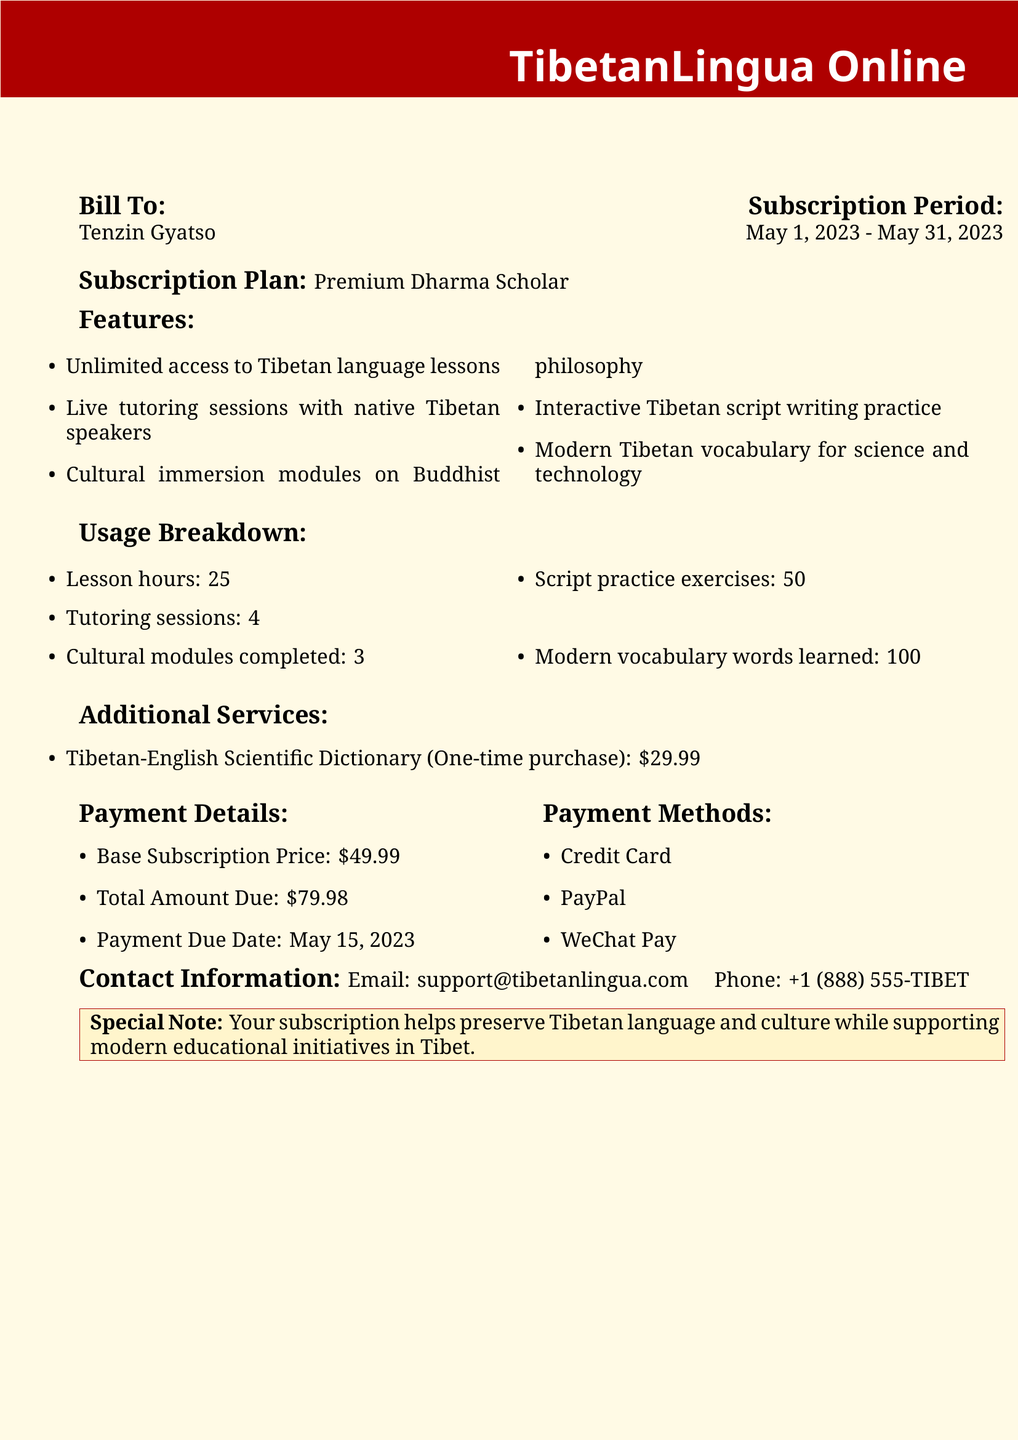What is the name of the platform? The name of the platform is mentioned at the top of the document as "TibetanLingua Online."
Answer: TibetanLingua Online Who is the bill addressed to? The bill is addressed to a specific person named in the document.
Answer: Tenzin Gyatso What is the subscription plan? The document specifies the subscription plan that the user has chosen.
Answer: Premium Dharma Scholar What is the total amount due? The total amount due is clearly stated in the payment details section of the document.
Answer: $79.98 How many tutoring sessions were completed? The document provides a breakdown of usage, including the number of tutoring sessions.
Answer: 4 What is the payment due date? The document mentions the specific date by which the payment must be made.
Answer: May 15, 2023 What is the price of the Tibetan-English Scientific Dictionary? The document lists the price of the additional service available for purchase.
Answer: $29.99 How many lesson hours were used? A specific number representing lesson hours is stated in the usage breakdown.
Answer: 25 What unique support does the subscription provide? The document includes a special note about the purpose of the subscription.
Answer: Preserve Tibetan language and culture 